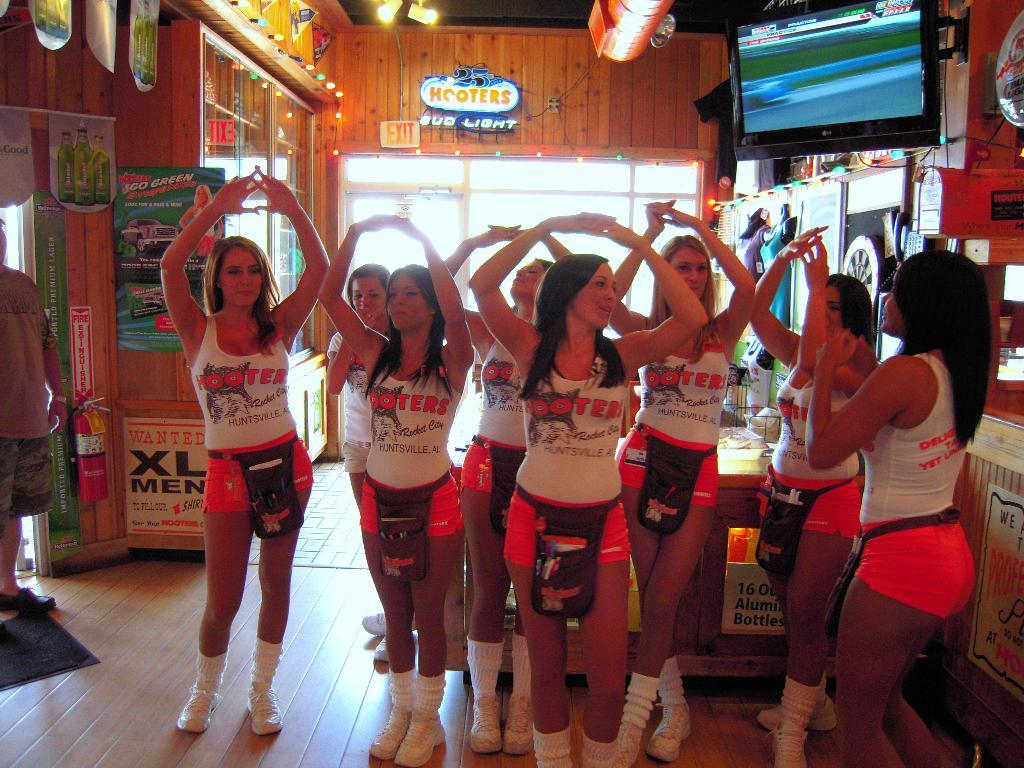Provide a one-sentence caption for the provided image. Group of Hooters girls standing together inside a room. 